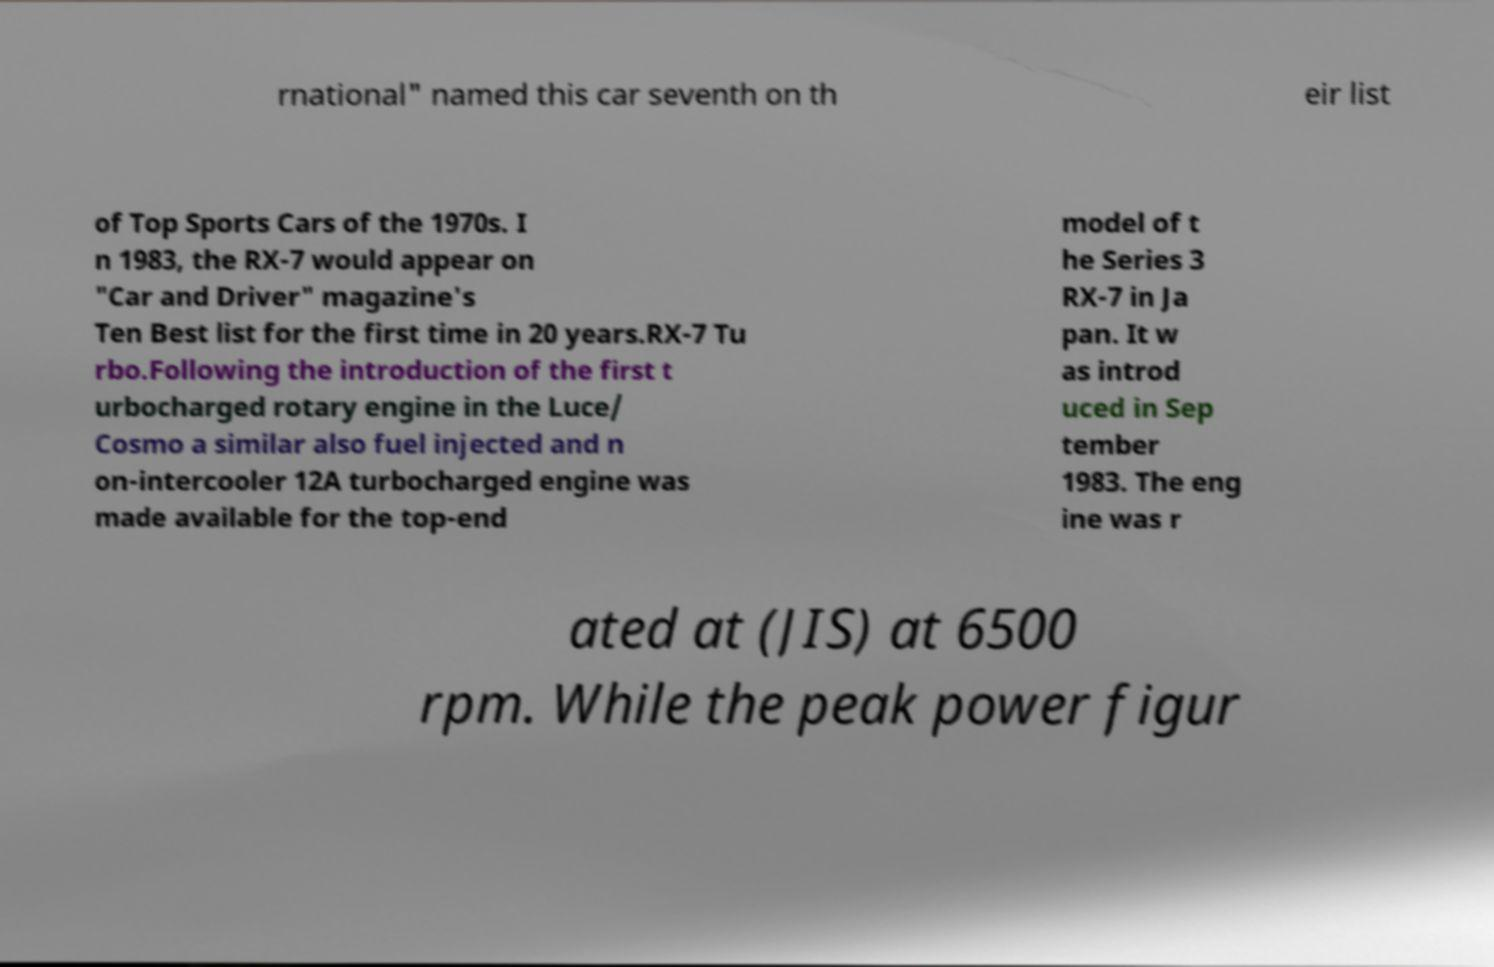Can you accurately transcribe the text from the provided image for me? rnational" named this car seventh on th eir list of Top Sports Cars of the 1970s. I n 1983, the RX-7 would appear on "Car and Driver" magazine's Ten Best list for the first time in 20 years.RX-7 Tu rbo.Following the introduction of the first t urbocharged rotary engine in the Luce/ Cosmo a similar also fuel injected and n on-intercooler 12A turbocharged engine was made available for the top-end model of t he Series 3 RX-7 in Ja pan. It w as introd uced in Sep tember 1983. The eng ine was r ated at (JIS) at 6500 rpm. While the peak power figur 